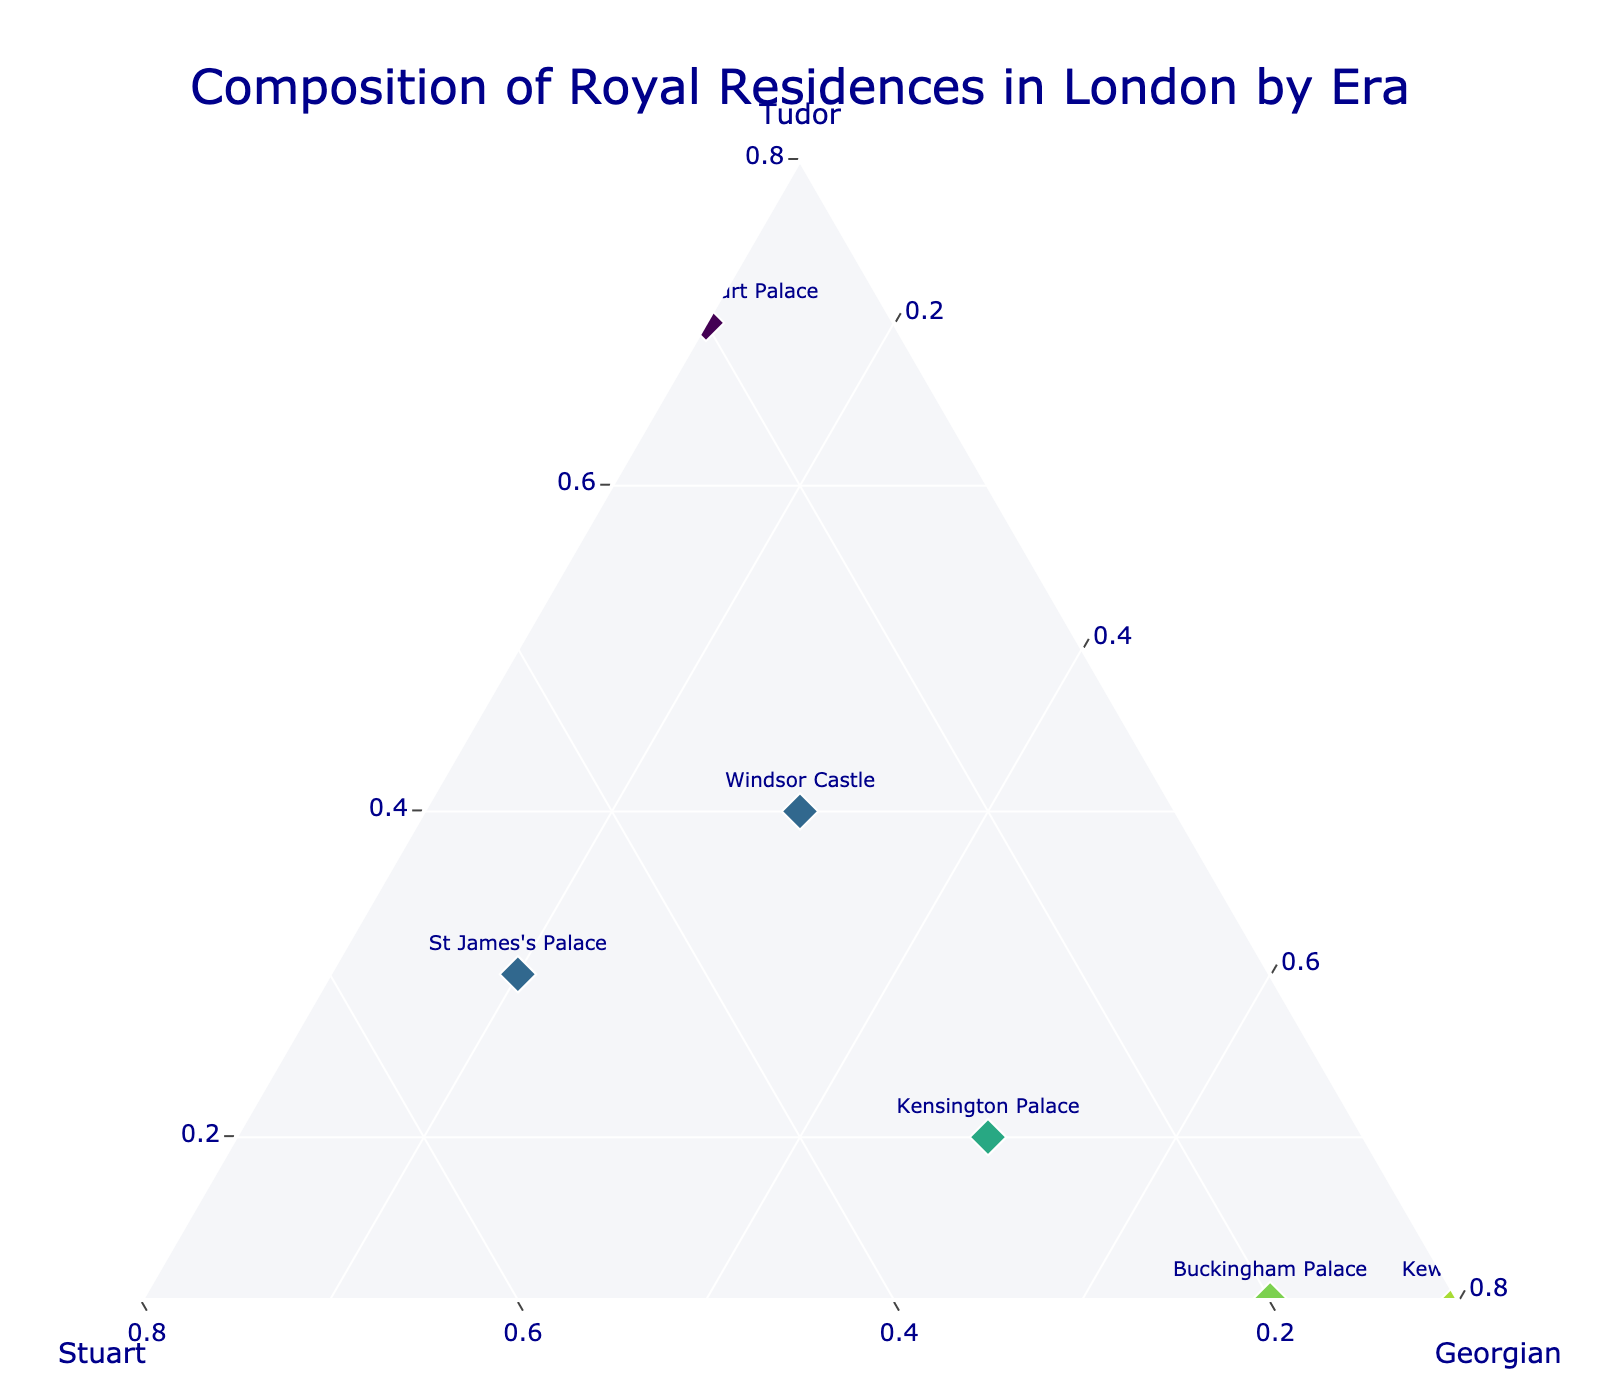What's the title of the figure? The title is displayed at the top center of the figure in large font.
Answer: Composition of Royal Residences in London by Era Which residence has the highest Georgian influence? Look for the data point positioned closest to the "Georgian" axis. This is represented as having the highest percentage for Georgian.
Answer: Buckingham Palace How many residences have more than 50% Tudor influence? Count the residences whose markers are positioned closer to the "Tudor" axis, indicating over 50% Tudor.
Answer: 2 What is the composition of Kew Palace in terms of the three eras? Locate Kew Palace in the plot; the coordinates give the composition as a division among the three axes.
Answer: Tudor: 0.1, Stuart: 0.1, Georgian: 0.8 Between Windsor Castle and St James's Palace, which has a higher Stuart influence? Compare the position of Windsor Castle and St James's Palace along the Stuart axis.
Answer: St James's Palace What is the average Tudor influence among all the residences displayed? Sum the Tudor values for all residences and divide by the number of residences. (0.1 + 0.2 + 0.7 + 0.3 + 0.4 + 0.1 + 0 + 0 + 0.6) / 9 = 0.267
Answer: 0.267 Which residence is equally influenced by Stuart and Georgian eras? Locate the data points where the Stuart and Georgian percentages are equal.
Answer: Windsor Castle Identify residences with more than 50% Georgian influence but less than 20% Tudor influence. Look for markers close to the Georgian axis and distant from the Tudor axis.
Answer: Buckingham Palace, Kew Palace, Carlton House Which residence shows almost no influence from the Tudor era? Find the residence with a value of 0.0 or close to 0.0 on the Tudor axis.
Answer: Banqueting House, Carlton House Among the residences, which one has the highest total influence from the Tudor and Stuart eras combined? Add the Tudor and Stuart values for each residence and find the highest sum. (Banqueting House: 0.9, Whitehall Palace: 1.0)
Answer: Whitehall Palace 